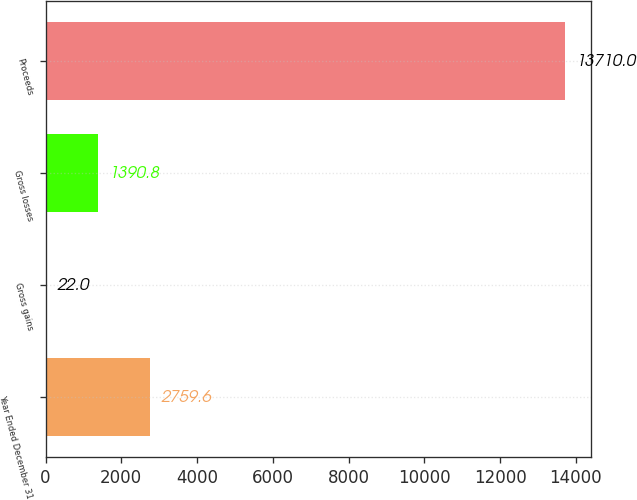Convert chart to OTSL. <chart><loc_0><loc_0><loc_500><loc_500><bar_chart><fcel>Year Ended December 31<fcel>Gross gains<fcel>Gross losses<fcel>Proceeds<nl><fcel>2759.6<fcel>22<fcel>1390.8<fcel>13710<nl></chart> 